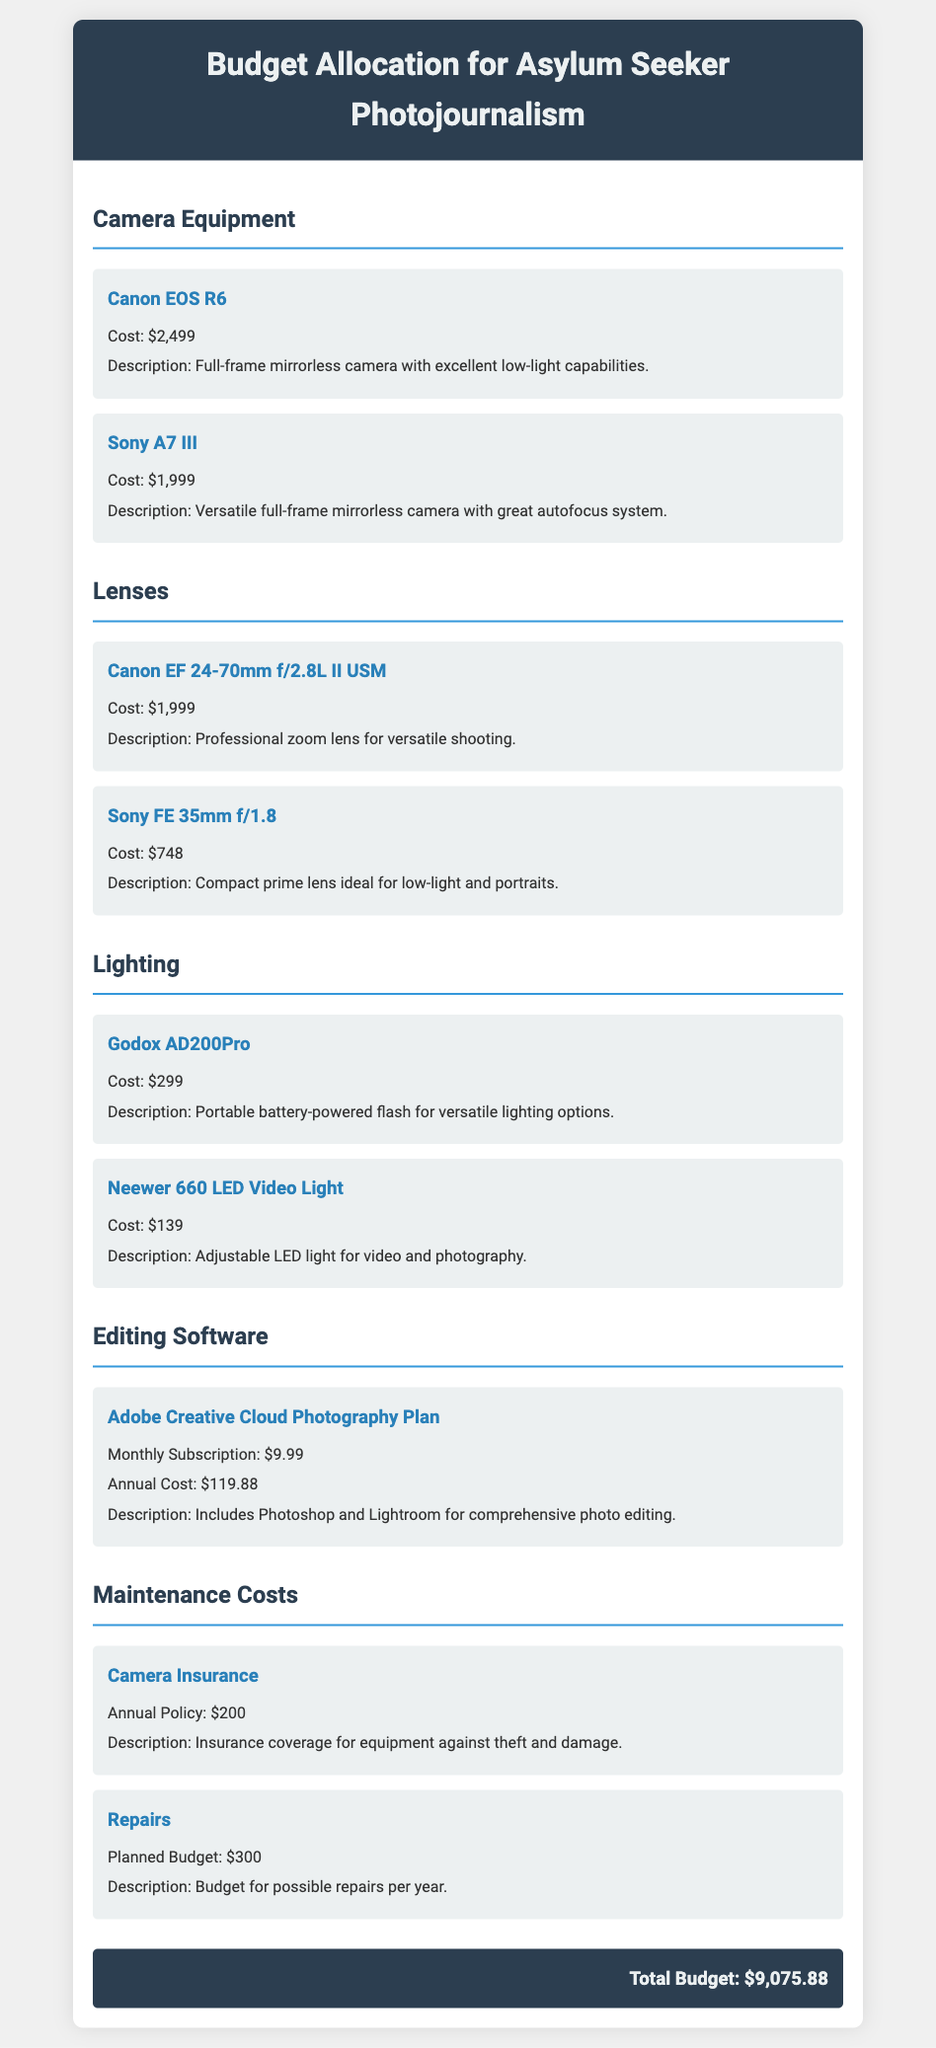What is the total budget? The total budget is the sum of all allocated costs in the document, which amounts to $9,075.88.
Answer: $9,075.88 What is the cost of the Canon EOS R6? The Canon EOS R6 is listed with a specific cost in the document, which is $2,499.
Answer: $2,499 How much does the Adobe Creative Cloud Photography Plan cost annually? The annual cost for the Adobe Creative Cloud Photography Plan is explicitly provided as $119.88.
Answer: $119.88 What type of camera is the Sony A7 III? The document describes the Sony A7 III as a versatile full-frame mirrorless camera.
Answer: full-frame mirrorless camera What is the planned budget for repairs? The planned budget for repairs is mentioned in the maintenance costs, which is set at $300.
Answer: $300 How many lighting items are listed in the budget? The document has two distinct lighting items described under the lighting section.
Answer: two What is the annual policy cost for camera insurance? The document specifies the annual policy cost for camera insurance as $200.
Answer: $200 What description is provided for the Neewer 660 LED Video Light? The document includes a description indicating that it is an adjustable LED light for video and photography.
Answer: Adjustable LED light for video and photography What is the cost of the Canon EF 24-70mm f/2.8L II USM lens? The Canon EF 24-70mm f/2.8L II USM lens is assigned a specific cost in the document, which is $1,999.
Answer: $1,999 